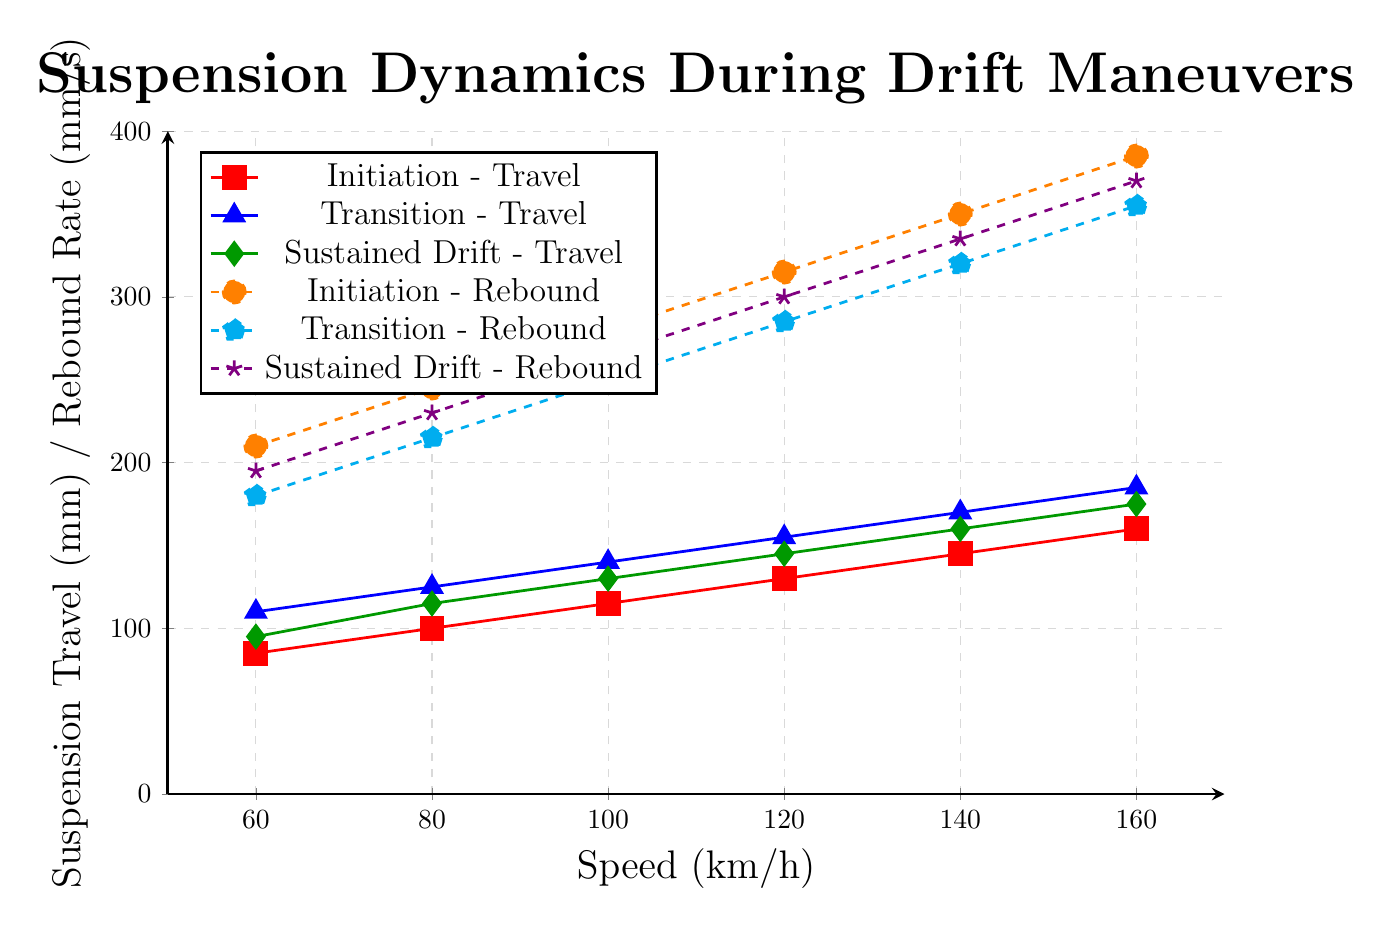What is the difference in suspension travel between initiation and sustained drift at 120 km/h? To find the difference, we look at the suspension travel values for initiation (130 mm) and sustained drift (145 mm) at 120 km/h. The difference is calculated as \(145 - 130 = 15\) mm
Answer: 15 mm How does the rebound rate change from initiation to transition at 140 km/h? We will compare the rebound rates for initiation (350 mm/s) and transition (320 mm/s) at 140 km/h. The change is \(320 - 350 = -30\) mm/s
Answer: -30 mm/s Which maneuver type shows the highest rebound rate at 100 km/h? We examine the rebound rate values at 100 km/h for each maneuver type: initiation (280 mm/s), transition (250 mm/s), and sustained drift (265 mm/s). The highest value is for initiation at 280 mm/s
Answer: Initiation Is the increase in suspension travel from initiation to transition at 160 km/h greater than the increase from transition to sustained drift? The increase from initiation to transition is \(185 - 160 = 25\) mm. The increase from transition to sustained drift is \(175 - 185 = -10\) mm. Comparing the two, 25 mm is greater than -10 mm
Answer: Yes At what speed does the initiation maneuver first exceed 100 mm in suspension travel? We look at the suspension travel values for the initiation maneuver: 85 mm (60 km/h), 100 mm (80 km/h), 115 mm (100 km/h). The first speed where it exceeds 100 mm is 100 km/h
Answer: 100 km/h Which maneuver type has the steepest increase in rebound rate as speed increases from 80 to 120 km/h? For each maneuver type, calculate the increase in rebound rate between 80 and 120 km/h: initiation (315 - 245 = 70 mm/s), transition (285 - 215 = 70 mm/s), sustained drift (300 - 230 = 70 mm/s). All have an increase of 70 mm/s, so transition shows the same increase as initiation and sustained drift
Answer: All maneuvers Compare the average suspension travel during transition maneuvers across all speeds to that during initiation maneuvers. The average travel for transition across all speeds: (110+125+140+155+170+185)/6 = 885/6 = 147.5 mm. For initiation (85+100+115+130+145+160)/6 = 735/6 = 122.5 mm. Transition maneuvers have a higher average suspension travel
Answer: Transition: 147.5 mm, Initiation: 122.5 mm Which color represents the sustained drift maneuver for suspension travel in the plot? By examining the legend, we find the sustained drift maneuver for suspension travel is marked in green
Answer: Green 